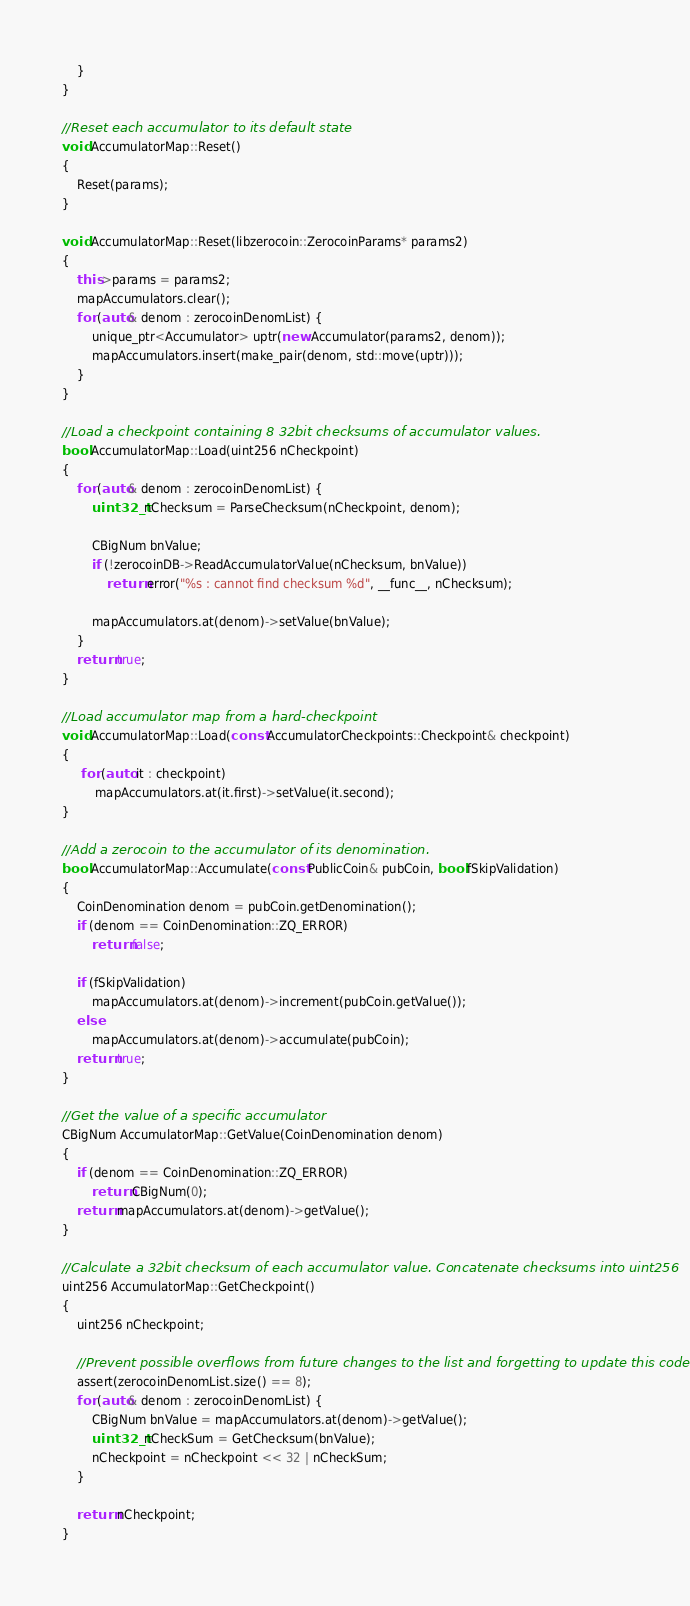<code> <loc_0><loc_0><loc_500><loc_500><_C++_>    }
}

//Reset each accumulator to its default state
void AccumulatorMap::Reset()
{
    Reset(params);
}

void AccumulatorMap::Reset(libzerocoin::ZerocoinParams* params2)
{
    this->params = params2;
    mapAccumulators.clear();
    for (auto& denom : zerocoinDenomList) {
        unique_ptr<Accumulator> uptr(new Accumulator(params2, denom));
        mapAccumulators.insert(make_pair(denom, std::move(uptr)));
    }
}

//Load a checkpoint containing 8 32bit checksums of accumulator values.
bool AccumulatorMap::Load(uint256 nCheckpoint)
{
    for (auto& denom : zerocoinDenomList) {
        uint32_t nChecksum = ParseChecksum(nCheckpoint, denom);

        CBigNum bnValue;
        if (!zerocoinDB->ReadAccumulatorValue(nChecksum, bnValue))
            return error("%s : cannot find checksum %d", __func__, nChecksum);

        mapAccumulators.at(denom)->setValue(bnValue);
    }
    return true;
}

//Load accumulator map from a hard-checkpoint
void AccumulatorMap::Load(const AccumulatorCheckpoints::Checkpoint& checkpoint)
{
     for (auto it : checkpoint)
         mapAccumulators.at(it.first)->setValue(it.second);
}

//Add a zerocoin to the accumulator of its denomination.
bool AccumulatorMap::Accumulate(const PublicCoin& pubCoin, bool fSkipValidation)
{
    CoinDenomination denom = pubCoin.getDenomination();
    if (denom == CoinDenomination::ZQ_ERROR)
        return false;

    if (fSkipValidation)
        mapAccumulators.at(denom)->increment(pubCoin.getValue());
    else
        mapAccumulators.at(denom)->accumulate(pubCoin);
    return true;
}

//Get the value of a specific accumulator
CBigNum AccumulatorMap::GetValue(CoinDenomination denom)
{
    if (denom == CoinDenomination::ZQ_ERROR)
        return CBigNum(0);
    return mapAccumulators.at(denom)->getValue();
}

//Calculate a 32bit checksum of each accumulator value. Concatenate checksums into uint256
uint256 AccumulatorMap::GetCheckpoint()
{
    uint256 nCheckpoint;

    //Prevent possible overflows from future changes to the list and forgetting to update this code
    assert(zerocoinDenomList.size() == 8);
    for (auto& denom : zerocoinDenomList) {
        CBigNum bnValue = mapAccumulators.at(denom)->getValue();
        uint32_t nCheckSum = GetChecksum(bnValue);
        nCheckpoint = nCheckpoint << 32 | nCheckSum;
    }

    return nCheckpoint;
}


</code> 